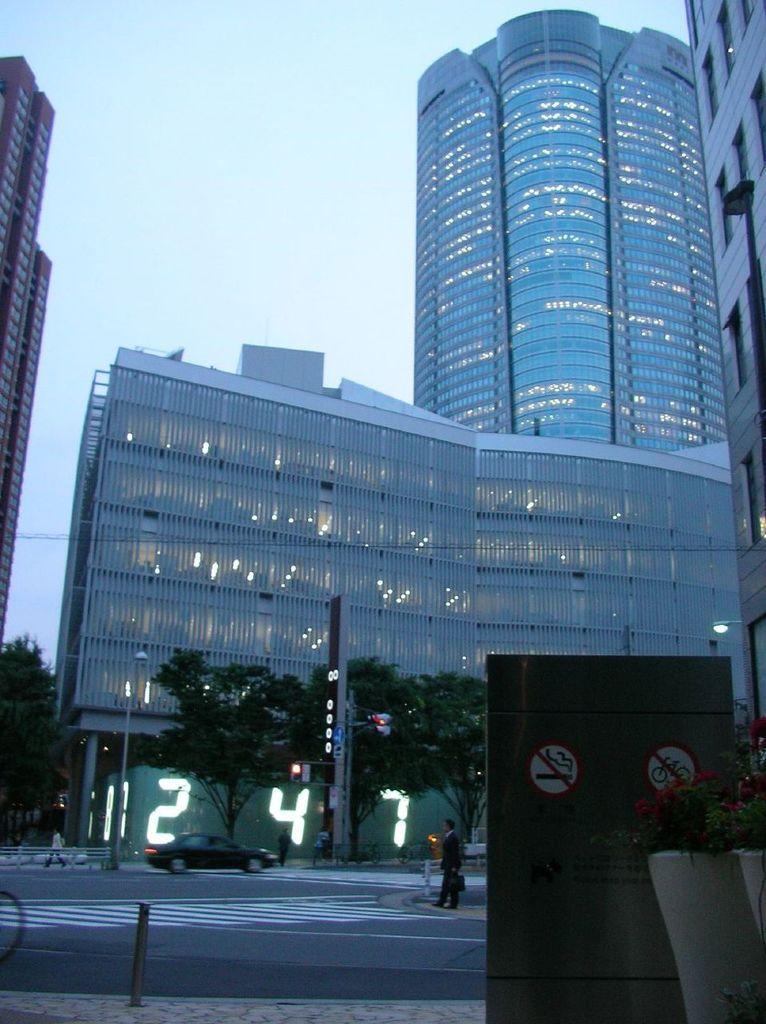Could you give a brief overview of what you see in this image? In this image there is a road in the bottom of this image and there is a car on the road. There is one person standing in the bottom of this image,and there are some trees in the background. There are some buildings in middle of this image and there is a sky on the top of this image. 